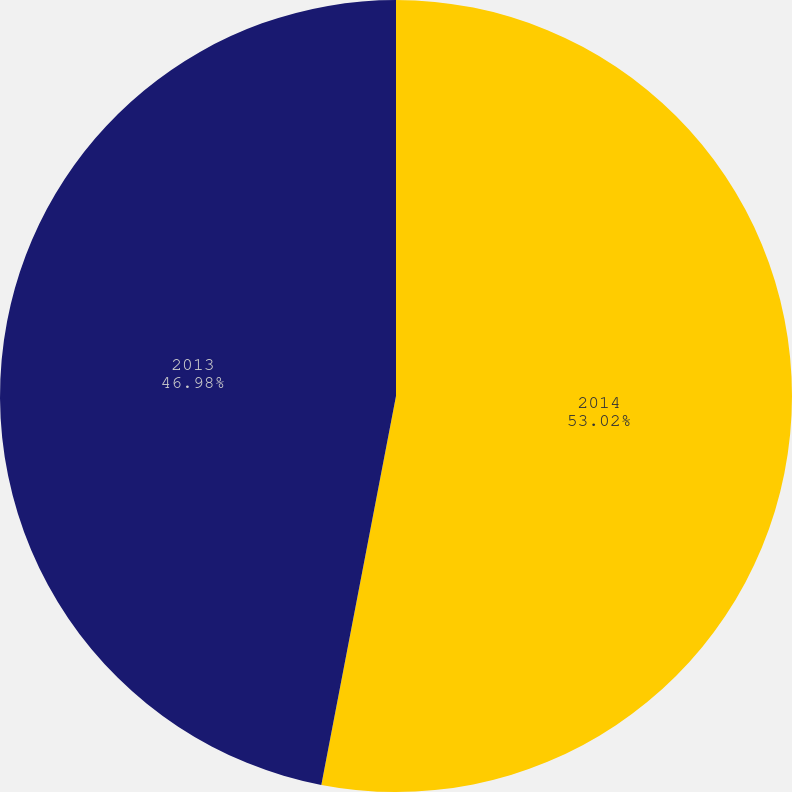<chart> <loc_0><loc_0><loc_500><loc_500><pie_chart><fcel>2014<fcel>2013<nl><fcel>53.02%<fcel>46.98%<nl></chart> 